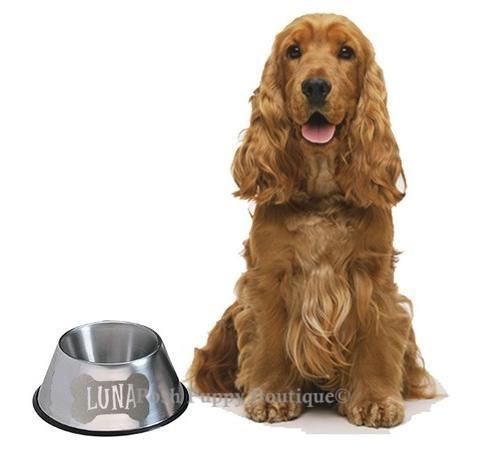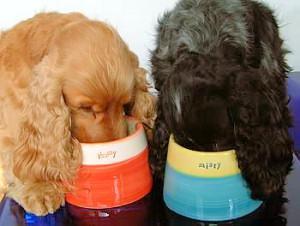The first image is the image on the left, the second image is the image on the right. Analyze the images presented: Is the assertion "The dog in the image on the left is eating out of a bowl." valid? Answer yes or no. No. The first image is the image on the left, the second image is the image on the right. Examine the images to the left and right. Is the description "An image includes an orange cocker spaniel with its nose in a dog bowl without a patterned design." accurate? Answer yes or no. Yes. 